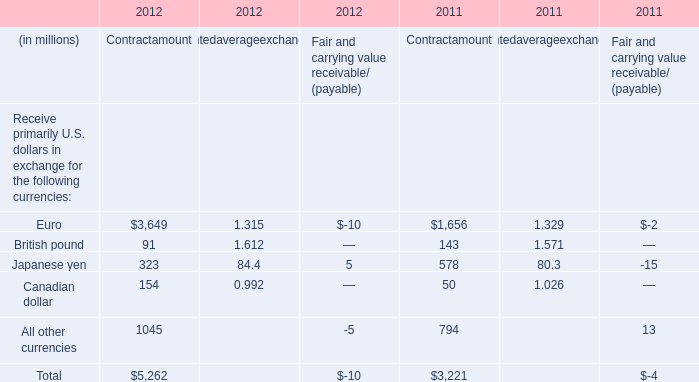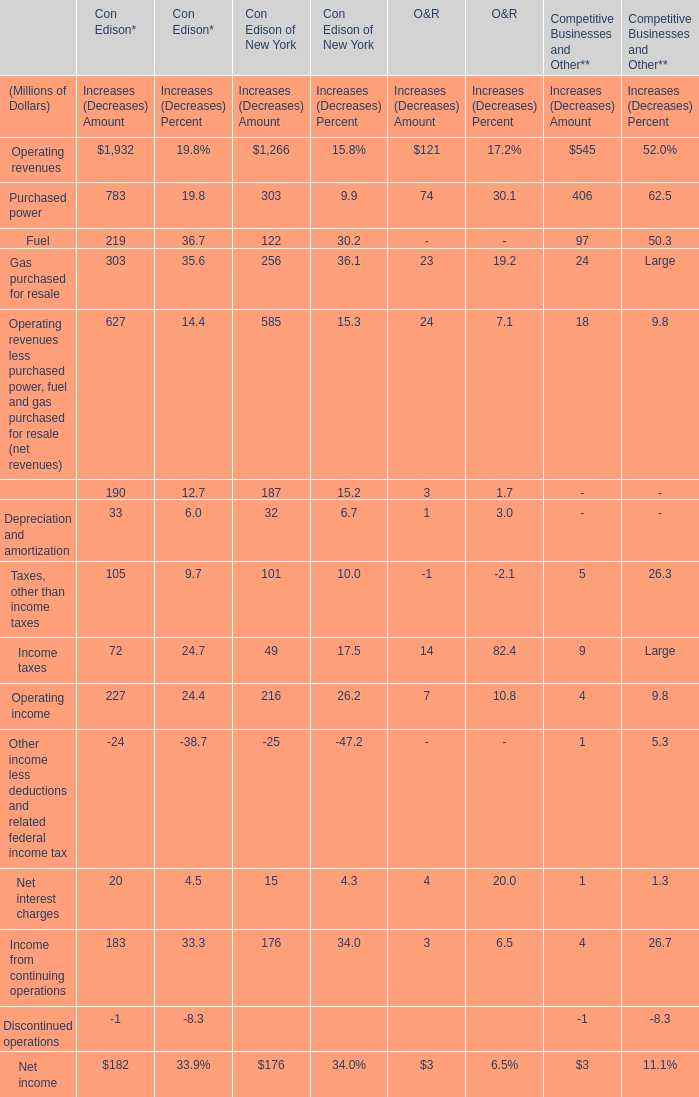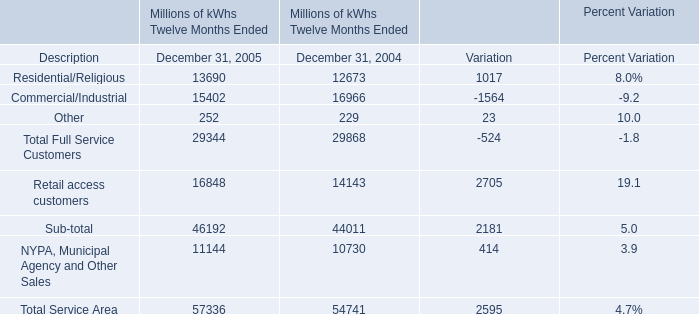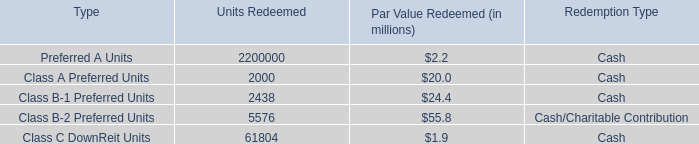what is the average , in millions , of noncontrolling interest relating to the remaining units in 2009-2010? 
Computations: ((110.4 + 113.1) / 2)
Answer: 111.75. 